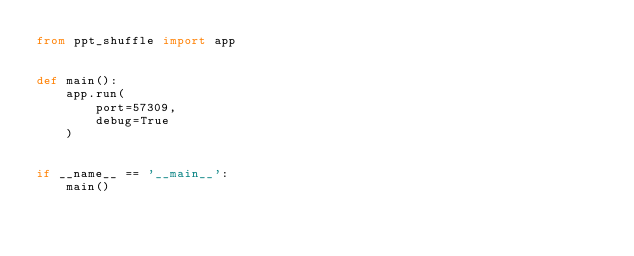Convert code to text. <code><loc_0><loc_0><loc_500><loc_500><_Python_>from ppt_shuffle import app


def main():
    app.run(
        port=57309,
        debug=True
    )


if __name__ == '__main__':
    main()
</code> 